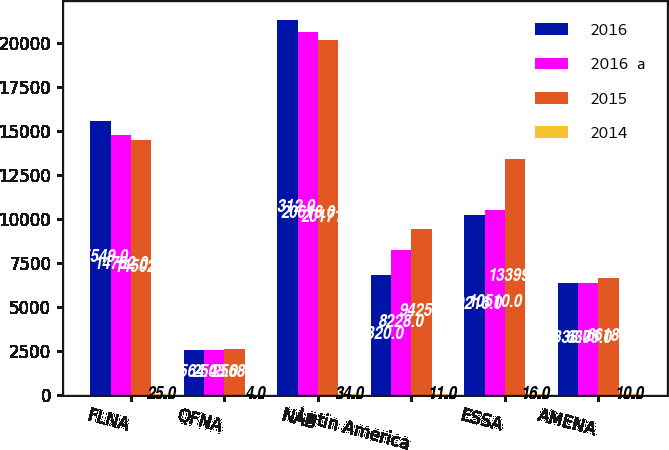<chart> <loc_0><loc_0><loc_500><loc_500><stacked_bar_chart><ecel><fcel>FLNA<fcel>QFNA<fcel>NAB<fcel>Latin America<fcel>ESSA<fcel>AMENA<nl><fcel>2016<fcel>15549<fcel>2564<fcel>21312<fcel>6820<fcel>10216<fcel>6338<nl><fcel>2016  a<fcel>14782<fcel>2543<fcel>20618<fcel>8228<fcel>10510<fcel>6375<nl><fcel>2015<fcel>14502<fcel>2568<fcel>20171<fcel>9425<fcel>13399<fcel>6618<nl><fcel>2014<fcel>25<fcel>4<fcel>34<fcel>11<fcel>16<fcel>10<nl></chart> 